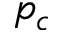Convert formula to latex. <formula><loc_0><loc_0><loc_500><loc_500>p _ { c }</formula> 